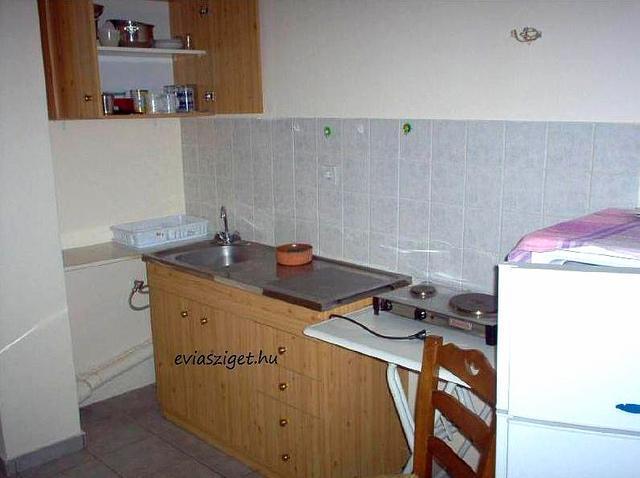What country is this?
Answer the question by selecting the correct answer among the 4 following choices and explain your choice with a short sentence. The answer should be formatted with the following format: `Answer: choice
Rationale: rationale.`
Options: Japan, usa, hungary, uk. Answer: hungary.
Rationale: The website says .hu, which is short for hungary. 